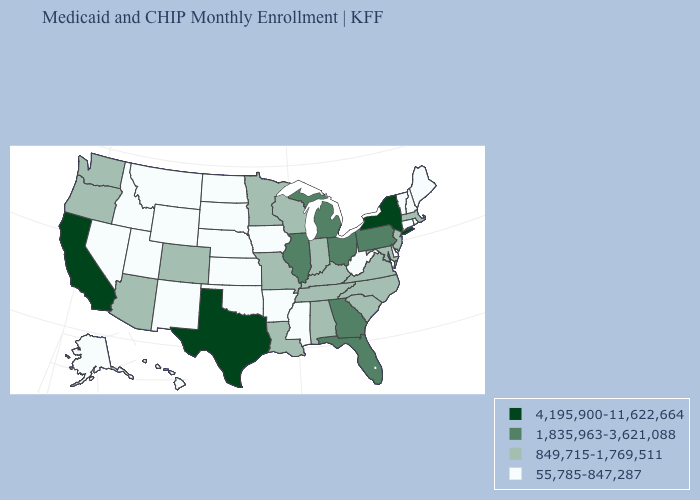How many symbols are there in the legend?
Quick response, please. 4. Name the states that have a value in the range 849,715-1,769,511?
Be succinct. Alabama, Arizona, Colorado, Indiana, Kentucky, Louisiana, Maryland, Massachusetts, Minnesota, Missouri, New Jersey, North Carolina, Oregon, South Carolina, Tennessee, Virginia, Washington, Wisconsin. Which states have the lowest value in the USA?
Short answer required. Alaska, Arkansas, Connecticut, Delaware, Hawaii, Idaho, Iowa, Kansas, Maine, Mississippi, Montana, Nebraska, Nevada, New Hampshire, New Mexico, North Dakota, Oklahoma, Rhode Island, South Dakota, Utah, Vermont, West Virginia, Wyoming. Among the states that border Alabama , does Georgia have the highest value?
Concise answer only. Yes. Name the states that have a value in the range 4,195,900-11,622,664?
Quick response, please. California, New York, Texas. What is the highest value in the MidWest ?
Give a very brief answer. 1,835,963-3,621,088. What is the lowest value in states that border North Carolina?
Quick response, please. 849,715-1,769,511. What is the value of Ohio?
Short answer required. 1,835,963-3,621,088. Name the states that have a value in the range 55,785-847,287?
Keep it brief. Alaska, Arkansas, Connecticut, Delaware, Hawaii, Idaho, Iowa, Kansas, Maine, Mississippi, Montana, Nebraska, Nevada, New Hampshire, New Mexico, North Dakota, Oklahoma, Rhode Island, South Dakota, Utah, Vermont, West Virginia, Wyoming. Does New York have the highest value in the Northeast?
Quick response, please. Yes. Does the map have missing data?
Quick response, please. No. Name the states that have a value in the range 4,195,900-11,622,664?
Write a very short answer. California, New York, Texas. Among the states that border Oregon , does Nevada have the lowest value?
Be succinct. Yes. What is the lowest value in the USA?
Be succinct. 55,785-847,287. 